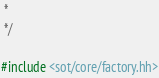Convert code to text. <code><loc_0><loc_0><loc_500><loc_500><_C++_> *
 */

#include <sot/core/factory.hh></code> 